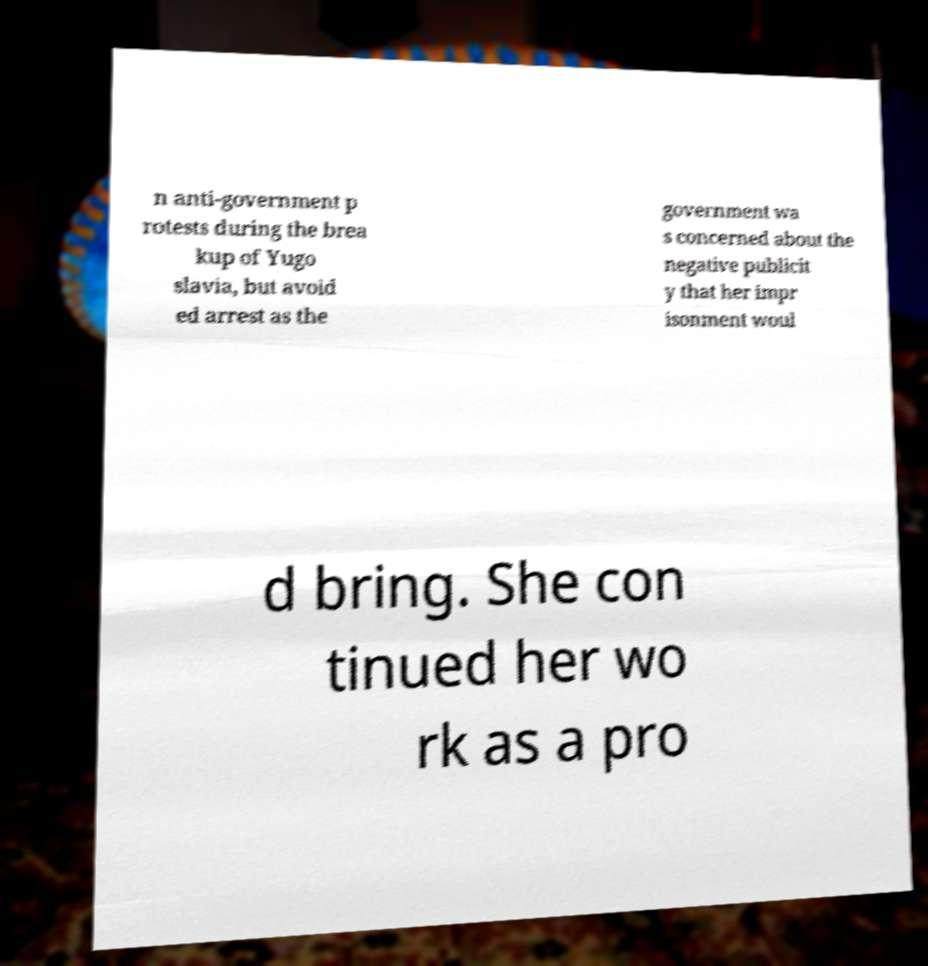Can you accurately transcribe the text from the provided image for me? n anti-government p rotests during the brea kup of Yugo slavia, but avoid ed arrest as the government wa s concerned about the negative publicit y that her impr isonment woul d bring. She con tinued her wo rk as a pro 